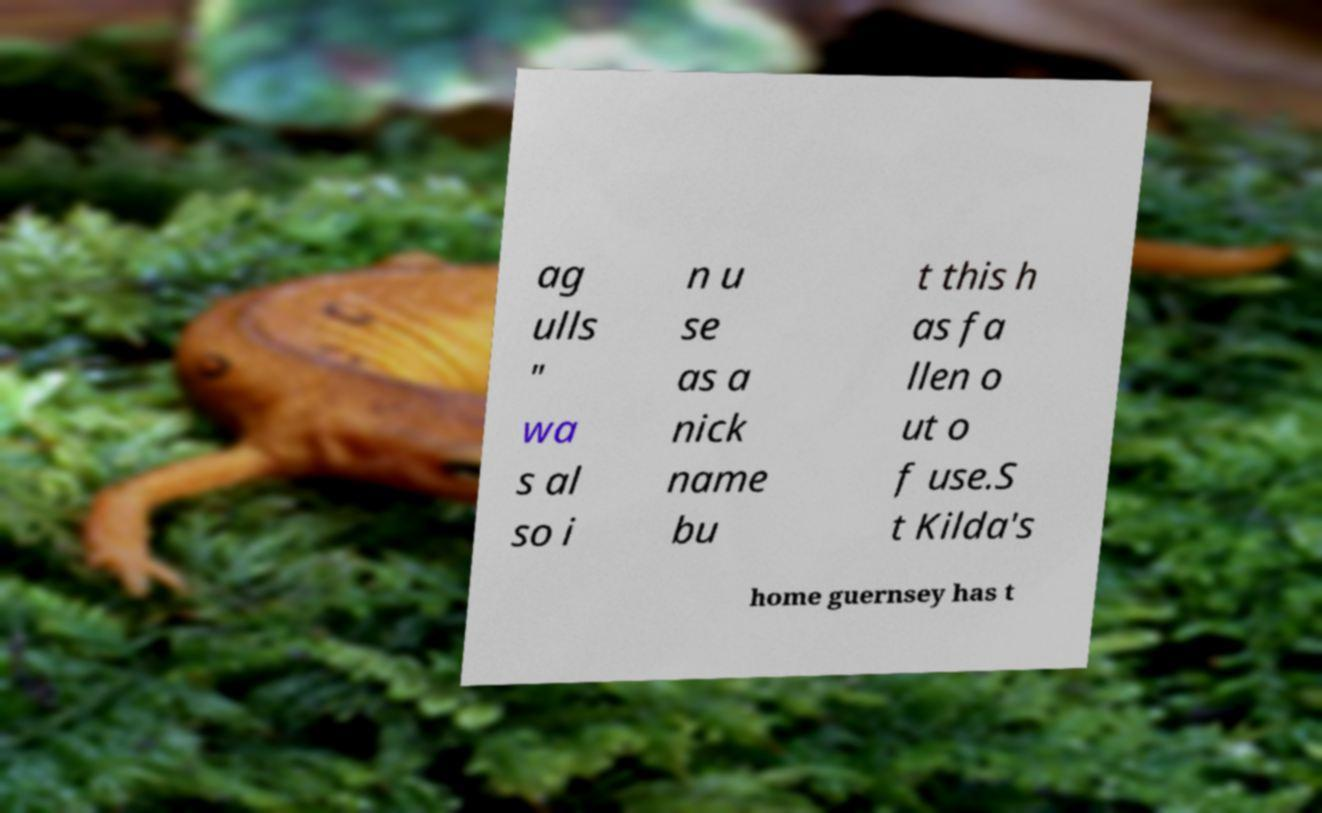Could you assist in decoding the text presented in this image and type it out clearly? ag ulls " wa s al so i n u se as a nick name bu t this h as fa llen o ut o f use.S t Kilda's home guernsey has t 